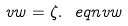Convert formula to latex. <formula><loc_0><loc_0><loc_500><loc_500>v w = \zeta . \ e q n { v w }</formula> 